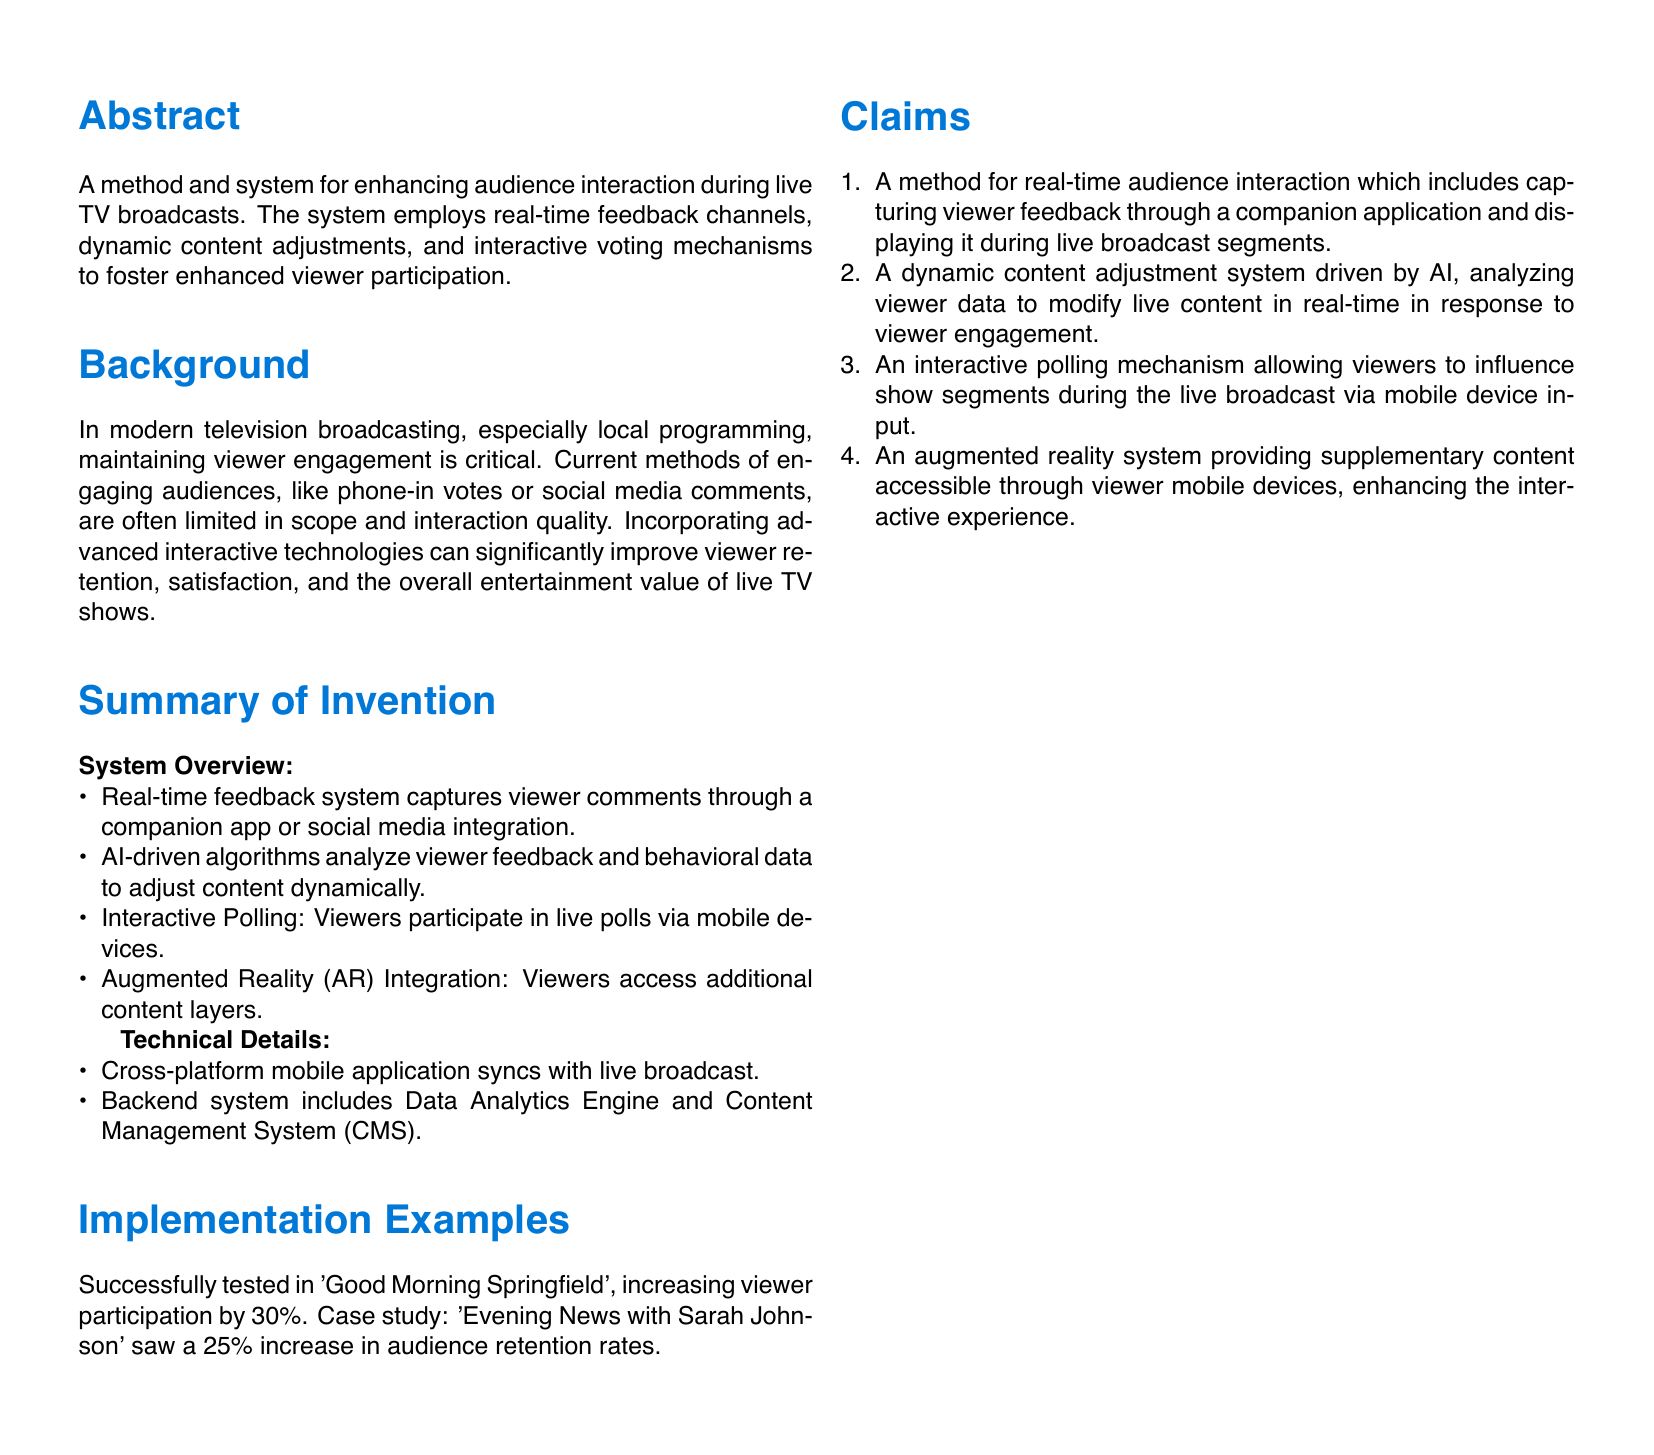what is the title of the patent application? The title is the main topic of the patent, which is stated prominently at the beginning of the document.
Answer: Interactive Audience Engagement System what percentage increase in viewer participation was noted in 'Good Morning Springfield'? This percentage is specifically mentioned in the implementation examples section, referring to a case study.
Answer: 30% how does the system enhance audience interaction? This refers to the overarching goal of the invention as stated in the abstract.
Answer: Real-time feedback channels what type of technology is integrated to provide supplementary content? This is mentioned in the claims section and relates to advanced interactive technologies.
Answer: Augmented Reality who is credited with the patent application? This is noted at the bottom of the document and provides authorship information.
Answer: Wittenberg University Alumnus what mechanism allows live voting participation from viewers? This refers to a specific feature of the system that promotes audience engagement during broadcasts.
Answer: Interactive Polling how much was the increase in audience retention for 'Evening News with Sarah Johnson'? This percentage shows the effectiveness of the system in another case study mentioned in the document.
Answer: 25% what is the main purpose of the Data Analytics Engine within the system? This question addresses the component of the backend system as outlined in the technical details.
Answer: Analyze viewer feedback and behavioral data 